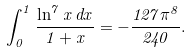<formula> <loc_0><loc_0><loc_500><loc_500>\int _ { 0 } ^ { 1 } \frac { \ln ^ { 7 } x \, d x } { 1 + x } = - \frac { 1 2 7 \pi ^ { 8 } } { 2 4 0 } .</formula> 